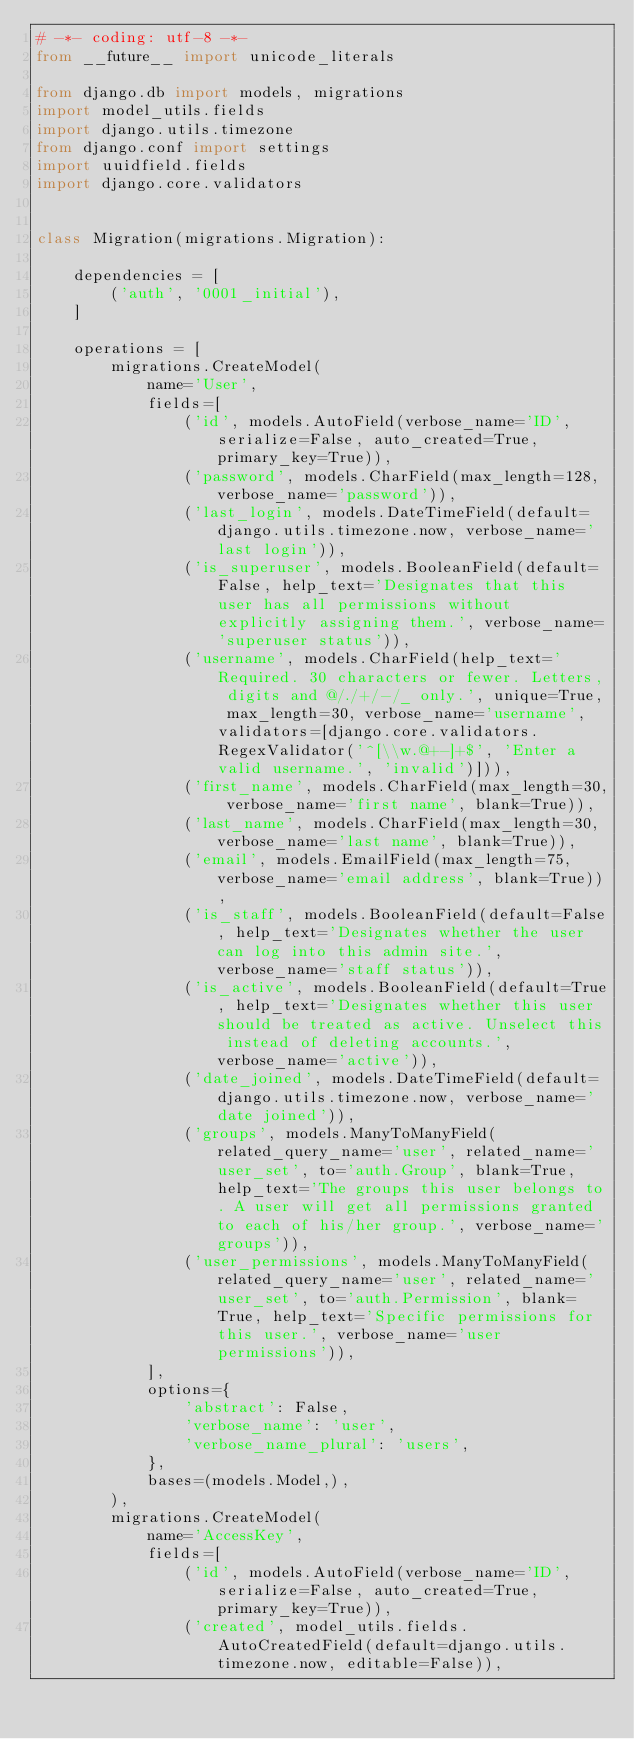<code> <loc_0><loc_0><loc_500><loc_500><_Python_># -*- coding: utf-8 -*-
from __future__ import unicode_literals

from django.db import models, migrations
import model_utils.fields
import django.utils.timezone
from django.conf import settings
import uuidfield.fields
import django.core.validators


class Migration(migrations.Migration):

    dependencies = [
        ('auth', '0001_initial'),
    ]

    operations = [
        migrations.CreateModel(
            name='User',
            fields=[
                ('id', models.AutoField(verbose_name='ID', serialize=False, auto_created=True, primary_key=True)),
                ('password', models.CharField(max_length=128, verbose_name='password')),
                ('last_login', models.DateTimeField(default=django.utils.timezone.now, verbose_name='last login')),
                ('is_superuser', models.BooleanField(default=False, help_text='Designates that this user has all permissions without explicitly assigning them.', verbose_name='superuser status')),
                ('username', models.CharField(help_text='Required. 30 characters or fewer. Letters, digits and @/./+/-/_ only.', unique=True, max_length=30, verbose_name='username', validators=[django.core.validators.RegexValidator('^[\\w.@+-]+$', 'Enter a valid username.', 'invalid')])),
                ('first_name', models.CharField(max_length=30, verbose_name='first name', blank=True)),
                ('last_name', models.CharField(max_length=30, verbose_name='last name', blank=True)),
                ('email', models.EmailField(max_length=75, verbose_name='email address', blank=True)),
                ('is_staff', models.BooleanField(default=False, help_text='Designates whether the user can log into this admin site.', verbose_name='staff status')),
                ('is_active', models.BooleanField(default=True, help_text='Designates whether this user should be treated as active. Unselect this instead of deleting accounts.', verbose_name='active')),
                ('date_joined', models.DateTimeField(default=django.utils.timezone.now, verbose_name='date joined')),
                ('groups', models.ManyToManyField(related_query_name='user', related_name='user_set', to='auth.Group', blank=True, help_text='The groups this user belongs to. A user will get all permissions granted to each of his/her group.', verbose_name='groups')),
                ('user_permissions', models.ManyToManyField(related_query_name='user', related_name='user_set', to='auth.Permission', blank=True, help_text='Specific permissions for this user.', verbose_name='user permissions')),
            ],
            options={
                'abstract': False,
                'verbose_name': 'user',
                'verbose_name_plural': 'users',
            },
            bases=(models.Model,),
        ),
        migrations.CreateModel(
            name='AccessKey',
            fields=[
                ('id', models.AutoField(verbose_name='ID', serialize=False, auto_created=True, primary_key=True)),
                ('created', model_utils.fields.AutoCreatedField(default=django.utils.timezone.now, editable=False)),</code> 